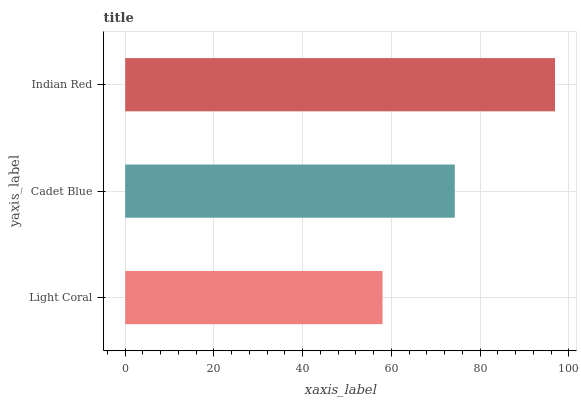Is Light Coral the minimum?
Answer yes or no. Yes. Is Indian Red the maximum?
Answer yes or no. Yes. Is Cadet Blue the minimum?
Answer yes or no. No. Is Cadet Blue the maximum?
Answer yes or no. No. Is Cadet Blue greater than Light Coral?
Answer yes or no. Yes. Is Light Coral less than Cadet Blue?
Answer yes or no. Yes. Is Light Coral greater than Cadet Blue?
Answer yes or no. No. Is Cadet Blue less than Light Coral?
Answer yes or no. No. Is Cadet Blue the high median?
Answer yes or no. Yes. Is Cadet Blue the low median?
Answer yes or no. Yes. Is Indian Red the high median?
Answer yes or no. No. Is Light Coral the low median?
Answer yes or no. No. 